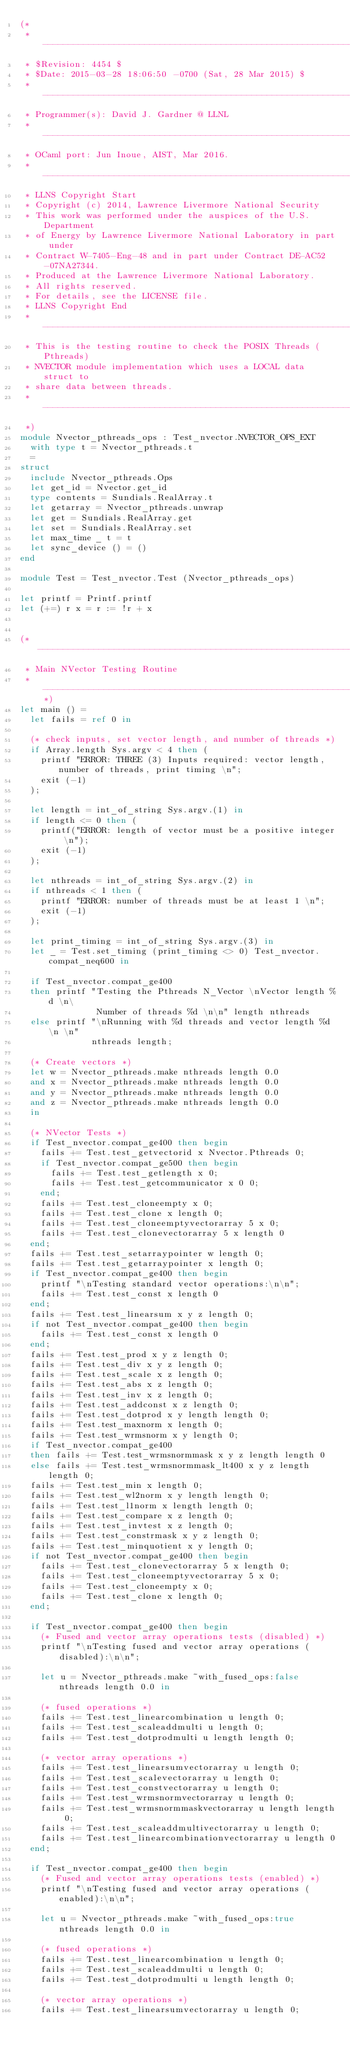Convert code to text. <code><loc_0><loc_0><loc_500><loc_500><_OCaml_>(*
 * -----------------------------------------------------------------
 * $Revision: 4454 $
 * $Date: 2015-03-28 18:06:50 -0700 (Sat, 28 Mar 2015) $
 * ----------------------------------------------------------------- 
 * Programmer(s): David J. Gardner @ LLNL
 * -----------------------------------------------------------------
 * OCaml port: Jun Inoue, AIST, Mar 2016.
 * -----------------------------------------------------------------
 * LLNS Copyright Start
 * Copyright (c) 2014, Lawrence Livermore National Security
 * This work was performed under the auspices of the U.S. Department 
 * of Energy by Lawrence Livermore National Laboratory in part under 
 * Contract W-7405-Eng-48 and in part under Contract DE-AC52-07NA27344.
 * Produced at the Lawrence Livermore National Laboratory.
 * All rights reserved.
 * For details, see the LICENSE file.
 * LLNS Copyright End
 * -----------------------------------------------------------------
 * This is the testing routine to check the POSIX Threads (Pthreads) 
 * NVECTOR module implementation which uses a LOCAL data struct to 
 * share data between threads. 
 * -----------------------------------------------------------------
 *)
module Nvector_pthreads_ops : Test_nvector.NVECTOR_OPS_EXT
  with type t = Nvector_pthreads.t
  =
struct
  include Nvector_pthreads.Ops
  let get_id = Nvector.get_id
  type contents = Sundials.RealArray.t
  let getarray = Nvector_pthreads.unwrap
  let get = Sundials.RealArray.get
  let set = Sundials.RealArray.set
  let max_time _ t = t
  let sync_device () = ()
end

module Test = Test_nvector.Test (Nvector_pthreads_ops)

let printf = Printf.printf
let (+=) r x = r := !r + x


(* ----------------------------------------------------------------------
 * Main NVector Testing Routine
 * --------------------------------------------------------------------*)
let main () =
  let fails = ref 0 in

  (* check inputs, set vector length, and number of threads *)
  if Array.length Sys.argv < 4 then (
    printf "ERROR: THREE (3) Inputs required: vector length, number of threads, print timing \n";
    exit (-1)
  );

  let length = int_of_string Sys.argv.(1) in
  if length <= 0 then (
    printf("ERROR: length of vector must be a positive integer \n");
    exit (-1)
  );

  let nthreads = int_of_string Sys.argv.(2) in
  if nthreads < 1 then (
    printf "ERROR: number of threads must be at least 1 \n";
    exit (-1)
  );

  let print_timing = int_of_string Sys.argv.(3) in
  let _ = Test.set_timing (print_timing <> 0) Test_nvector.compat_neq600 in

  if Test_nvector.compat_ge400
  then printf "Testing the Pthreads N_Vector \nVector length %d \n\
               Number of threads %d \n\n" length nthreads
  else printf "\nRunning with %d threads and vector length %d \n \n"
              nthreads length;

  (* Create vectors *)
  let w = Nvector_pthreads.make nthreads length 0.0
  and x = Nvector_pthreads.make nthreads length 0.0
  and y = Nvector_pthreads.make nthreads length 0.0
  and z = Nvector_pthreads.make nthreads length 0.0
  in

  (* NVector Tests *)
  if Test_nvector.compat_ge400 then begin
    fails += Test.test_getvectorid x Nvector.Pthreads 0;
    if Test_nvector.compat_ge500 then begin
      fails += Test.test_getlength x 0;
      fails += Test.test_getcommunicator x 0 0;
    end;
    fails += Test.test_cloneempty x 0;
    fails += Test.test_clone x length 0;
    fails += Test.test_cloneemptyvectorarray 5 x 0;
    fails += Test.test_clonevectorarray 5 x length 0
  end;
  fails += Test.test_setarraypointer w length 0;
  fails += Test.test_getarraypointer x length 0;
  if Test_nvector.compat_ge400 then begin
    printf "\nTesting standard vector operations:\n\n";
    fails += Test.test_const x length 0
  end;
  fails += Test.test_linearsum x y z length 0;
  if not Test_nvector.compat_ge400 then begin
    fails += Test.test_const x length 0
  end;
  fails += Test.test_prod x y z length 0;
  fails += Test.test_div x y z length 0;
  fails += Test.test_scale x z length 0;
  fails += Test.test_abs x z length 0;
  fails += Test.test_inv x z length 0;
  fails += Test.test_addconst x z length 0;
  fails += Test.test_dotprod x y length length 0;
  fails += Test.test_maxnorm x length 0;
  fails += Test.test_wrmsnorm x y length 0;
  if Test_nvector.compat_ge400
  then fails += Test.test_wrmsnormmask x y z length length 0
  else fails += Test.test_wrmsnormmask_lt400 x y z length length 0;
  fails += Test.test_min x length 0;
  fails += Test.test_wl2norm x y length length 0;
  fails += Test.test_l1norm x length length 0;
  fails += Test.test_compare x z length 0;
  fails += Test.test_invtest x z length 0;
  fails += Test.test_constrmask x y z length 0;
  fails += Test.test_minquotient x y length 0;
  if not Test_nvector.compat_ge400 then begin
    fails += Test.test_clonevectorarray 5 x length 0;
    fails += Test.test_cloneemptyvectorarray 5 x 0;
    fails += Test.test_cloneempty x 0;
    fails += Test.test_clone x length 0;
  end;

  if Test_nvector.compat_ge400 then begin
    (* Fused and vector array operations tests (disabled) *)
    printf "\nTesting fused and vector array operations (disabled):\n\n";

    let u = Nvector_pthreads.make ~with_fused_ops:false nthreads length 0.0 in

    (* fused operations *)
    fails += Test.test_linearcombination u length 0;
    fails += Test.test_scaleaddmulti u length 0;
    fails += Test.test_dotprodmulti u length length 0;

    (* vector array operations *)
    fails += Test.test_linearsumvectorarray u length 0;
    fails += Test.test_scalevectorarray u length 0;
    fails += Test.test_constvectorarray u length 0;
    fails += Test.test_wrmsnormvectorarray u length 0;
    fails += Test.test_wrmsnormmaskvectorarray u length length 0;
    fails += Test.test_scaleaddmultivectorarray u length 0;
    fails += Test.test_linearcombinationvectorarray u length 0
  end;

  if Test_nvector.compat_ge400 then begin
    (* Fused and vector array operations tests (enabled) *)
    printf "\nTesting fused and vector array operations (enabled):\n\n";

    let u = Nvector_pthreads.make ~with_fused_ops:true nthreads length 0.0 in

    (* fused operations *)
    fails += Test.test_linearcombination u length 0;
    fails += Test.test_scaleaddmulti u length 0;
    fails += Test.test_dotprodmulti u length length 0;

    (* vector array operations *)
    fails += Test.test_linearsumvectorarray u length 0;</code> 